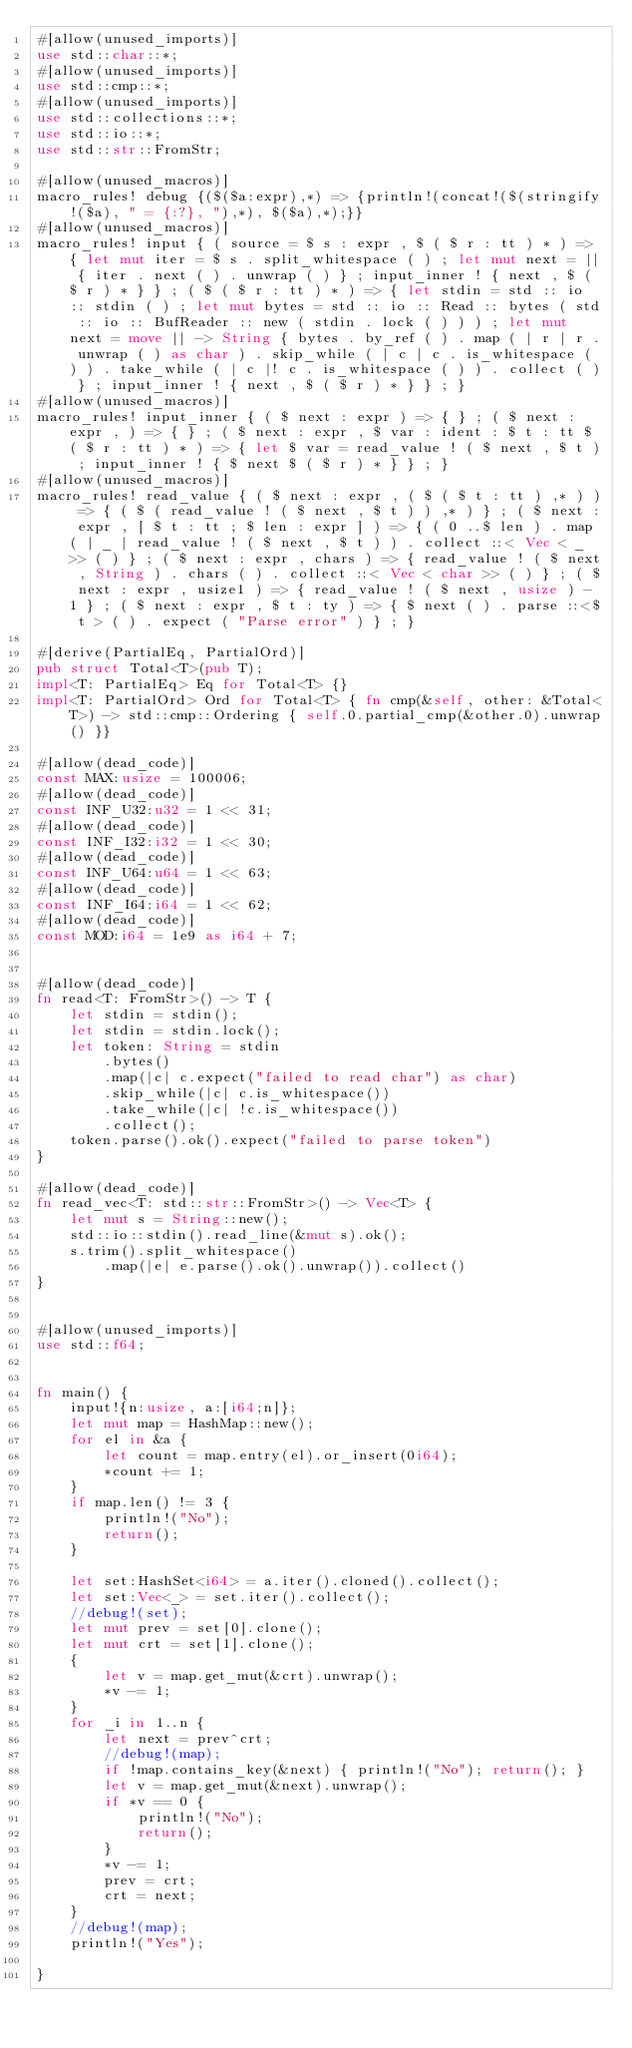Convert code to text. <code><loc_0><loc_0><loc_500><loc_500><_Rust_>#[allow(unused_imports)]
use std::char::*;
#[allow(unused_imports)]
use std::cmp::*;
#[allow(unused_imports)]
use std::collections::*;
use std::io::*;
use std::str::FromStr;

#[allow(unused_macros)]
macro_rules! debug {($($a:expr),*) => {println!(concat!($(stringify!($a), " = {:?}, "),*), $($a),*);}}
#[allow(unused_macros)]
macro_rules! input { ( source = $ s : expr , $ ( $ r : tt ) * ) => { let mut iter = $ s . split_whitespace ( ) ; let mut next = || { iter . next ( ) . unwrap ( ) } ; input_inner ! { next , $ ( $ r ) * } } ; ( $ ( $ r : tt ) * ) => { let stdin = std :: io :: stdin ( ) ; let mut bytes = std :: io :: Read :: bytes ( std :: io :: BufReader :: new ( stdin . lock ( ) ) ) ; let mut next = move || -> String { bytes . by_ref ( ) . map ( | r | r . unwrap ( ) as char ) . skip_while ( | c | c . is_whitespace ( ) ) . take_while ( | c |! c . is_whitespace ( ) ) . collect ( ) } ; input_inner ! { next , $ ( $ r ) * } } ; }
#[allow(unused_macros)]
macro_rules! input_inner { ( $ next : expr ) => { } ; ( $ next : expr , ) => { } ; ( $ next : expr , $ var : ident : $ t : tt $ ( $ r : tt ) * ) => { let $ var = read_value ! ( $ next , $ t ) ; input_inner ! { $ next $ ( $ r ) * } } ; }
#[allow(unused_macros)]
macro_rules! read_value { ( $ next : expr , ( $ ( $ t : tt ) ,* ) ) => { ( $ ( read_value ! ( $ next , $ t ) ) ,* ) } ; ( $ next : expr , [ $ t : tt ; $ len : expr ] ) => { ( 0 ..$ len ) . map ( | _ | read_value ! ( $ next , $ t ) ) . collect ::< Vec < _ >> ( ) } ; ( $ next : expr , chars ) => { read_value ! ( $ next , String ) . chars ( ) . collect ::< Vec < char >> ( ) } ; ( $ next : expr , usize1 ) => { read_value ! ( $ next , usize ) - 1 } ; ( $ next : expr , $ t : ty ) => { $ next ( ) . parse ::<$ t > ( ) . expect ( "Parse error" ) } ; }

#[derive(PartialEq, PartialOrd)]
pub struct Total<T>(pub T);
impl<T: PartialEq> Eq for Total<T> {}
impl<T: PartialOrd> Ord for Total<T> { fn cmp(&self, other: &Total<T>) -> std::cmp::Ordering { self.0.partial_cmp(&other.0).unwrap() }}

#[allow(dead_code)]
const MAX:usize = 100006;
#[allow(dead_code)]
const INF_U32:u32 = 1 << 31;
#[allow(dead_code)]
const INF_I32:i32 = 1 << 30;
#[allow(dead_code)]
const INF_U64:u64 = 1 << 63;
#[allow(dead_code)]
const INF_I64:i64 = 1 << 62;
#[allow(dead_code)]
const MOD:i64 = 1e9 as i64 + 7;


#[allow(dead_code)]
fn read<T: FromStr>() -> T {
    let stdin = stdin();
    let stdin = stdin.lock();
    let token: String = stdin
        .bytes()
        .map(|c| c.expect("failed to read char") as char)
        .skip_while(|c| c.is_whitespace())
        .take_while(|c| !c.is_whitespace())
        .collect();
    token.parse().ok().expect("failed to parse token")
}

#[allow(dead_code)]
fn read_vec<T: std::str::FromStr>() -> Vec<T> {
    let mut s = String::new();
    std::io::stdin().read_line(&mut s).ok();
    s.trim().split_whitespace()
        .map(|e| e.parse().ok().unwrap()).collect()
}


#[allow(unused_imports)]
use std::f64;


fn main() {
    input!{n:usize, a:[i64;n]};
    let mut map = HashMap::new();
    for el in &a {
        let count = map.entry(el).or_insert(0i64);
        *count += 1;
    }
    if map.len() != 3 {
        println!("No");
        return();
    }

    let set:HashSet<i64> = a.iter().cloned().collect();
    let set:Vec<_> = set.iter().collect();
    //debug!(set);
    let mut prev = set[0].clone();
    let mut crt = set[1].clone();
    {
        let v = map.get_mut(&crt).unwrap();
        *v -= 1;
    }
    for _i in 1..n {
        let next = prev^crt;
        //debug!(map);
        if !map.contains_key(&next) { println!("No"); return(); }
        let v = map.get_mut(&next).unwrap();
        if *v == 0 {
            println!("No");
            return();
        }
        *v -= 1;
        prev = crt;
        crt = next;
    }
    //debug!(map);
    println!("Yes");

}</code> 